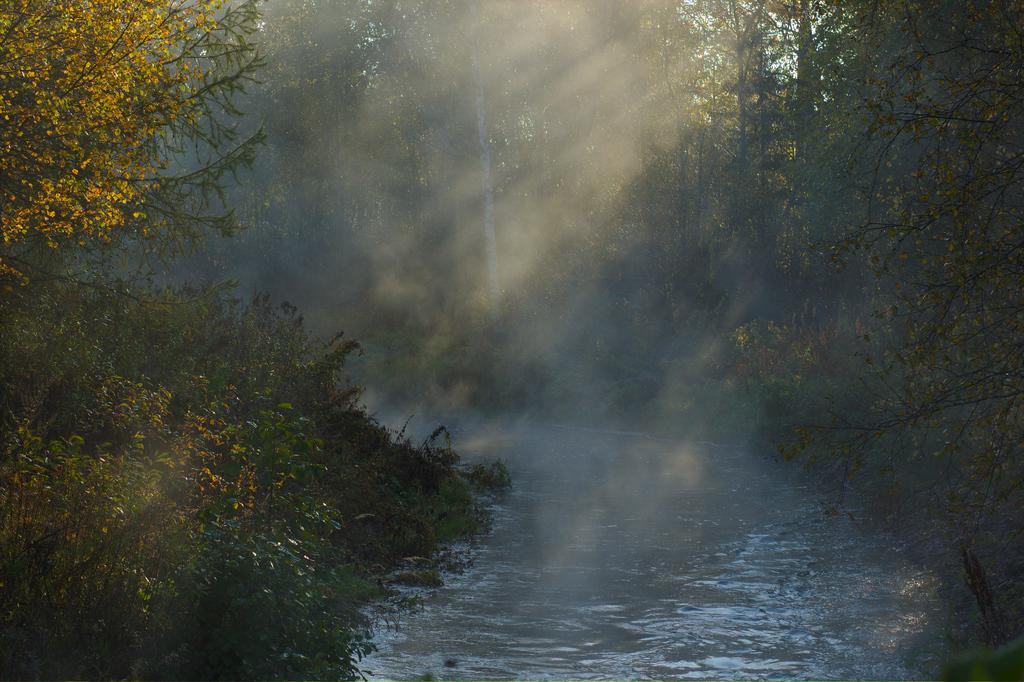Can you describe this image briefly? In this image in the front there are trees. In the center there is water. In the background there are trees. 